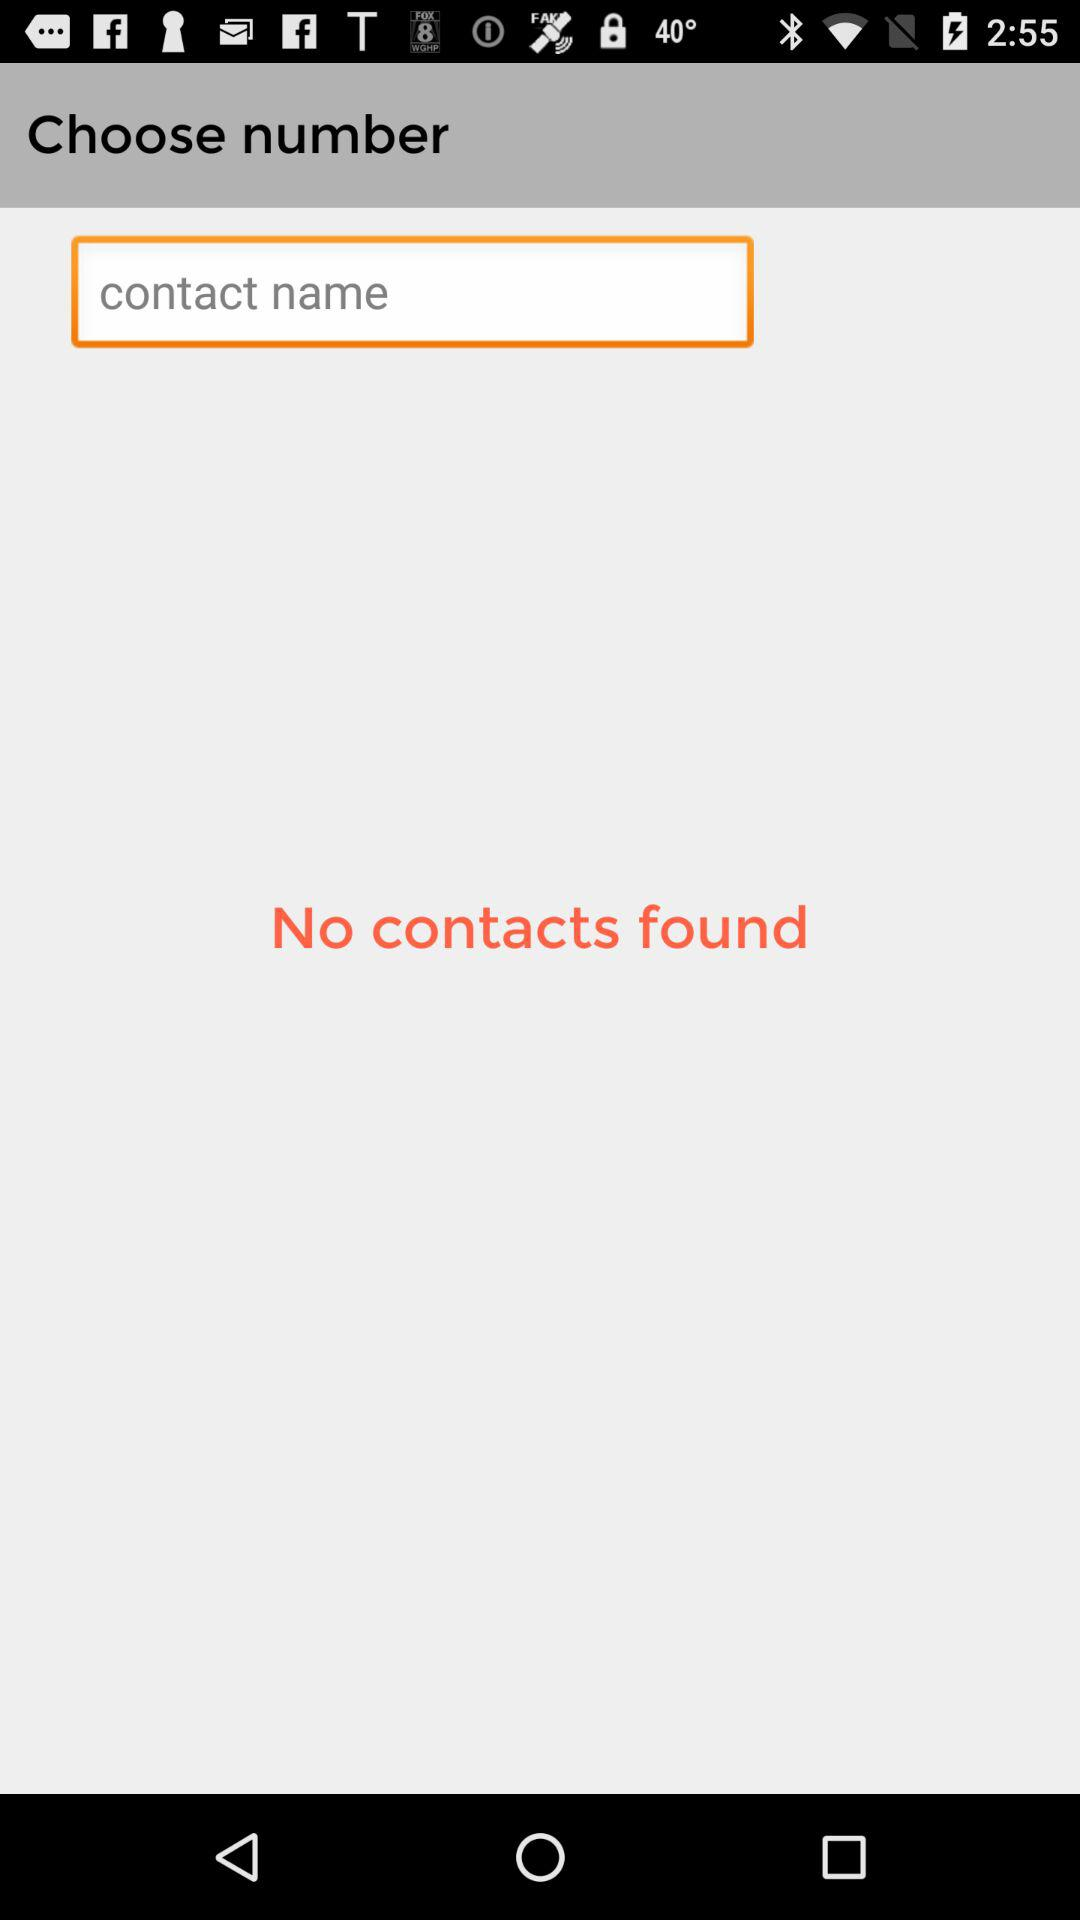Were there any contacts found? There were no contacts found. 